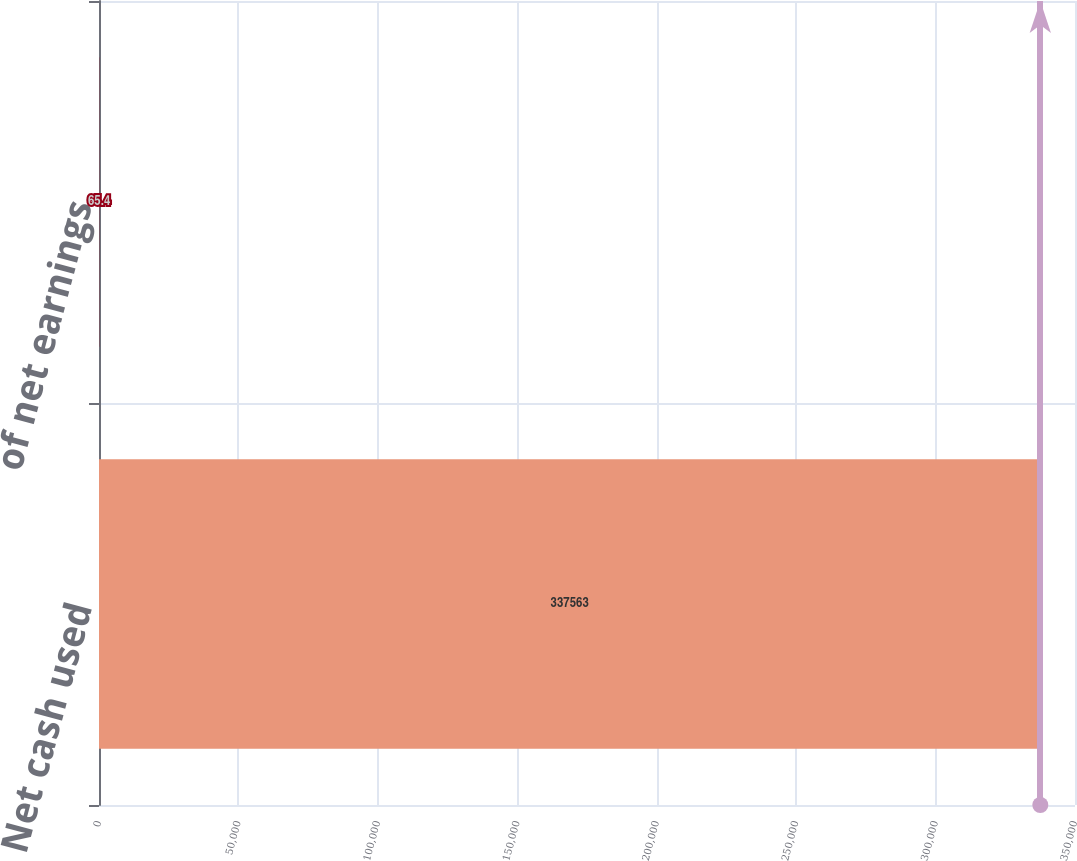Convert chart. <chart><loc_0><loc_0><loc_500><loc_500><bar_chart><fcel>Net cash used<fcel>of net earnings<nl><fcel>337563<fcel>65.4<nl></chart> 